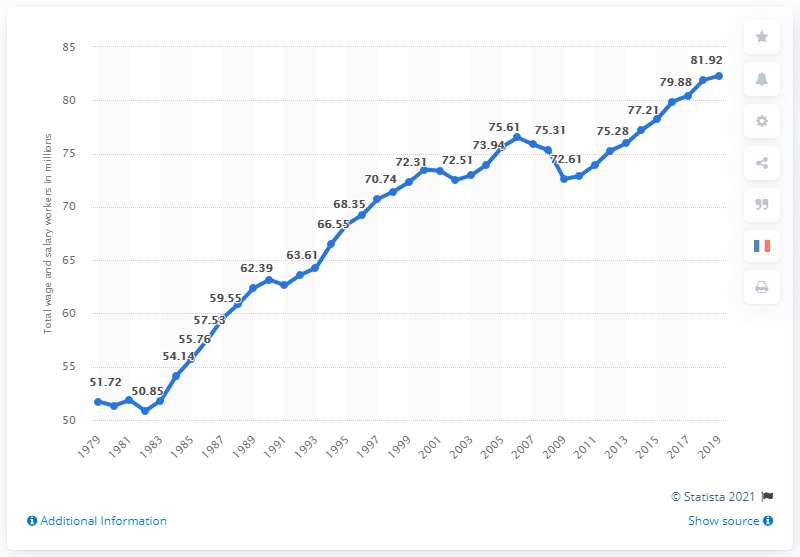Draw attention to some important aspects in this diagram. In 2019, the United States had 82,290 workers who were paid hourly rates. 